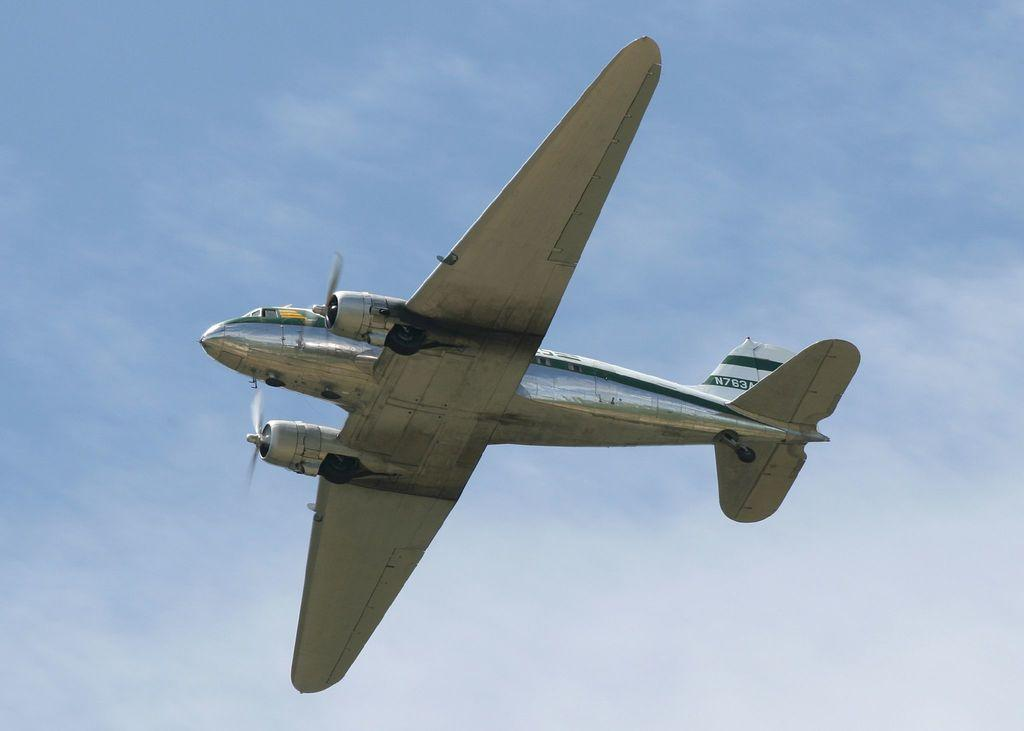What is the main subject of the image? The main subject of the image is an aeroplane. What is the aeroplane doing in the image? The aeroplane is flying in the sky. What type of cough medicine is visible in the image? There is no cough medicine present in the image; it features an aeroplane flying in the sky. What type of tub is shown in the image? There is no tub present in the image. 